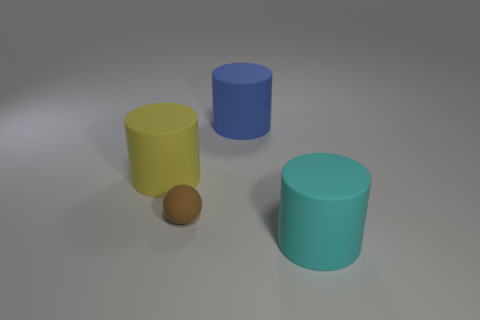Does the brown ball have the same material as the large blue object?
Make the answer very short. Yes. What number of cylinders are to the right of the brown thing and to the left of the large cyan cylinder?
Give a very brief answer. 1. What number of other things are there of the same color as the rubber sphere?
Keep it short and to the point. 0. How many yellow objects are either matte cylinders or rubber cubes?
Provide a succinct answer. 1. How big is the cyan thing?
Give a very brief answer. Large. How many matte things are blue things or small purple things?
Your response must be concise. 1. Are there fewer big blue matte objects than small blue metal cubes?
Your response must be concise. No. What number of other things are there of the same material as the yellow thing
Keep it short and to the point. 3. What is the size of the yellow matte thing that is the same shape as the big cyan object?
Your answer should be very brief. Large. Are the small brown thing that is on the left side of the blue cylinder and the thing on the left side of the brown ball made of the same material?
Your answer should be very brief. Yes. 